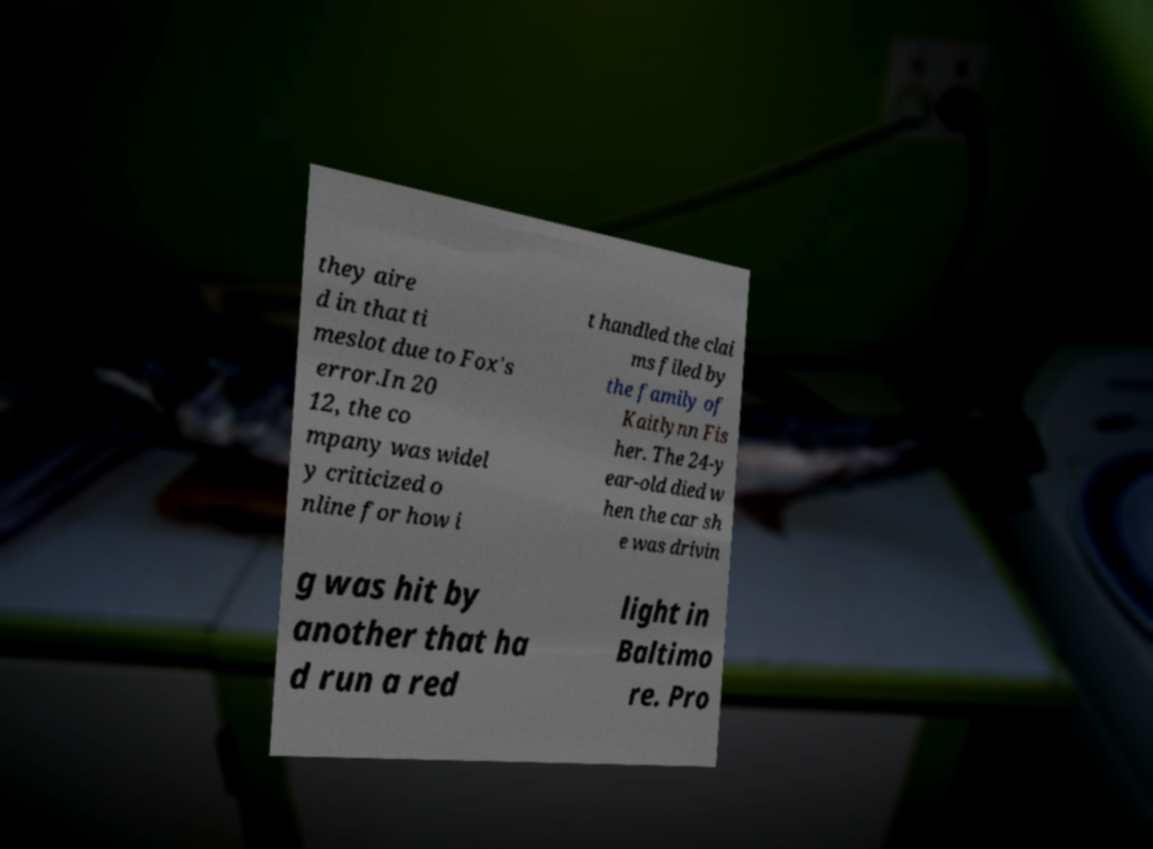Could you extract and type out the text from this image? they aire d in that ti meslot due to Fox's error.In 20 12, the co mpany was widel y criticized o nline for how i t handled the clai ms filed by the family of Kaitlynn Fis her. The 24-y ear-old died w hen the car sh e was drivin g was hit by another that ha d run a red light in Baltimo re. Pro 